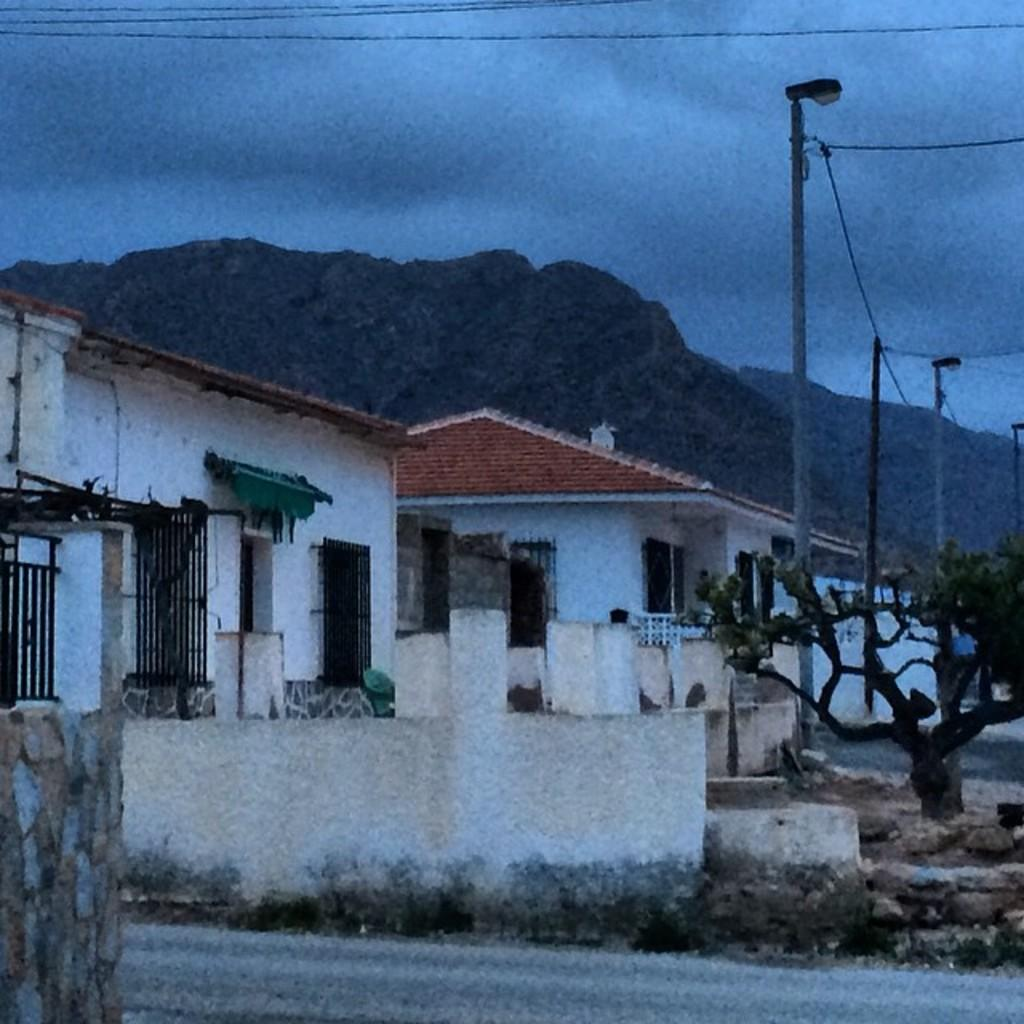What type of pathway is visible in the image? There is a road in the image. What other structures can be seen in the image? There is a wall, a tree, poles, wires, and buildings in the image. What natural feature is visible in the background of the image? There is a mountain visible in the background of the image. What else can be seen in the background of the image? The sky is visible in the background of the image. What type of paint is being used to create the waves in the image? There are no waves present in the image; it features a road, a wall, a tree, poles, wires, buildings, a mountain, and the sky. What is the friction between the poles and the wires in the image? The image does not provide information about the friction between the poles and the wires; it only shows their presence. 